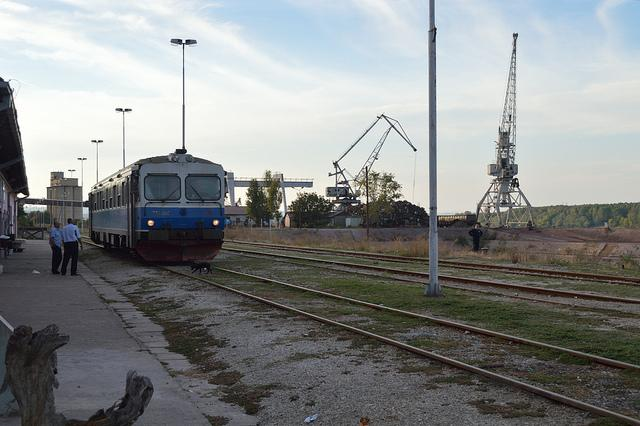Which entity is in the greatest danger? Please explain your reasoning. dog. A dog is in the middle of a track where a train is approaching. 